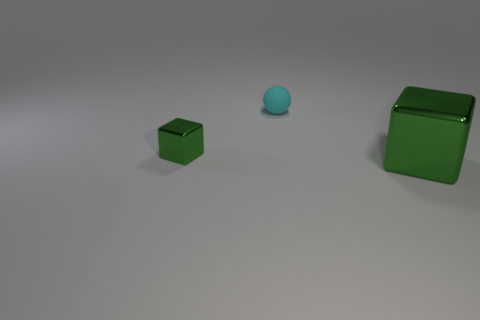Do the objects in the picture look like they could be used for a specific purpose? The objects in the picture appear to be simplistic geometric shapes, which suggests they could be used for educational or illustrative purposes, such as demonstrating size comparison, geometry, or color differentiation. 